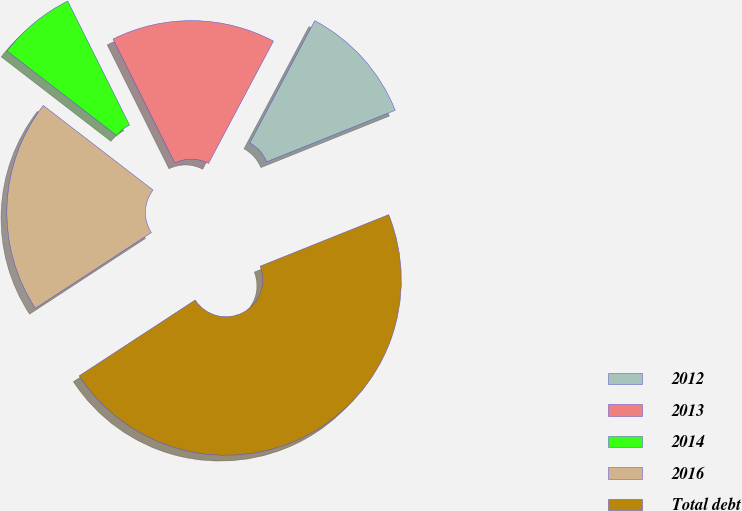Convert chart to OTSL. <chart><loc_0><loc_0><loc_500><loc_500><pie_chart><fcel>2012<fcel>2013<fcel>2014<fcel>2016<fcel>Total debt<nl><fcel>11.16%<fcel>15.13%<fcel>7.19%<fcel>19.66%<fcel>46.86%<nl></chart> 